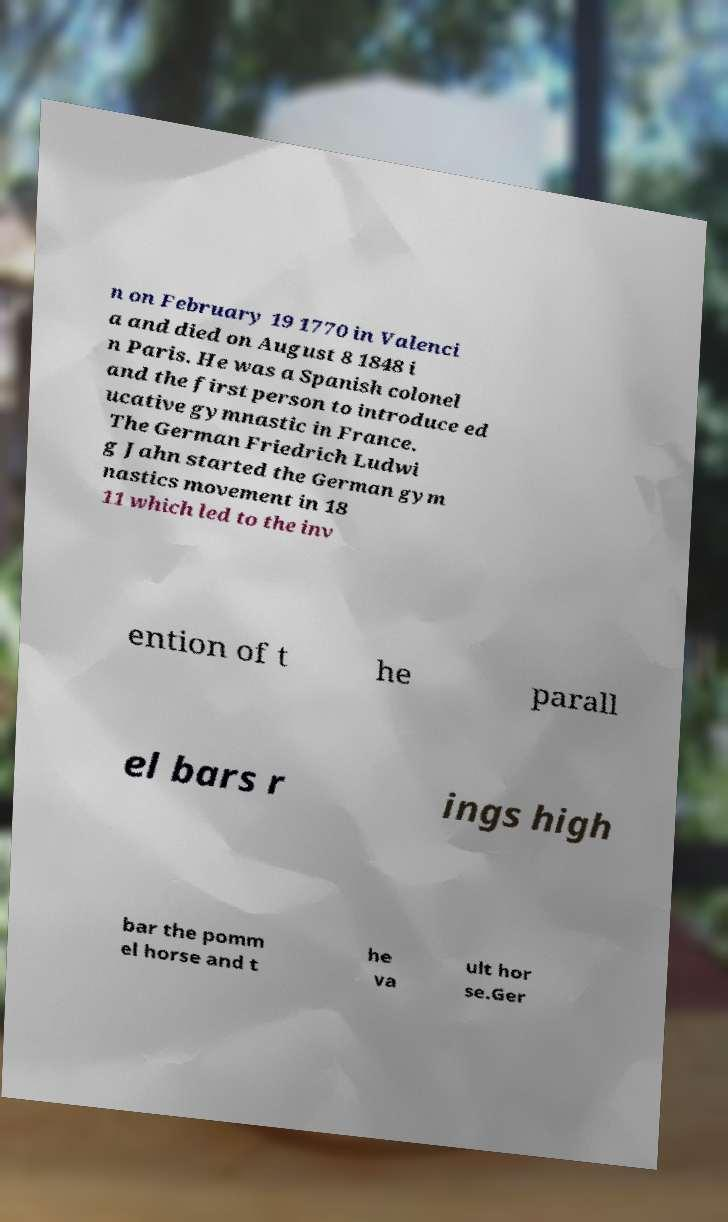Can you read and provide the text displayed in the image?This photo seems to have some interesting text. Can you extract and type it out for me? n on February 19 1770 in Valenci a and died on August 8 1848 i n Paris. He was a Spanish colonel and the first person to introduce ed ucative gymnastic in France. The German Friedrich Ludwi g Jahn started the German gym nastics movement in 18 11 which led to the inv ention of t he parall el bars r ings high bar the pomm el horse and t he va ult hor se.Ger 